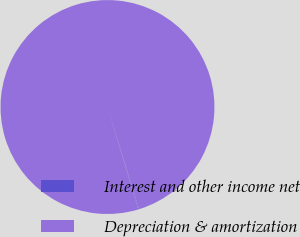Convert chart. <chart><loc_0><loc_0><loc_500><loc_500><pie_chart><fcel>Interest and other income net<fcel>Depreciation & amortization<nl><fcel>0.09%<fcel>99.91%<nl></chart> 